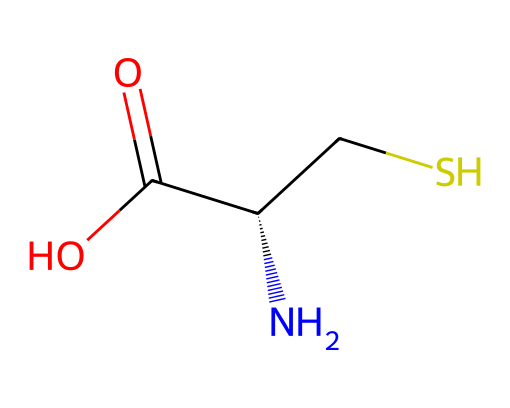What is the name of this compound? The SMILES representation indicates that the compound is cysteine, as it reflects the amino acid structure with a thiol group (CS).
Answer: cysteine How many carbon atoms are present in this structure? By analyzing the SMILES, there are two carbon atoms in the main chain (C and CS).
Answer: 2 What functional group is present in this amino acid? The presence of the “-SH” (thiol) in the structure indicates that this amino acid contains a thiol group.
Answer: thiol What type of bond connects the carbon and sulfur atoms? The carbon and sulfur in the thiol group (CS) are connected by a single covalent bond, as denoted in the SMILES.
Answer: single Does this compound contain an amine group? The presence of "N" in the SMILES indicates that there is indeed an amine group attached to the carbon backbone of the amino acid.
Answer: yes What is the total number of atoms in this structure? The structure includes: 3 carbon (C), 7 hydrogen (H), 1 nitrogen (N), and 2 oxygen (O) atoms, totaling to 13 atoms.
Answer: 13 Which aspect of this amino acid allows for the formation of disulfide bonds? The presence of the sulfur atom (-SH) in cysteine allows for the formation of disulfide bonds with another cysteine molecule.
Answer: sulfur atom 